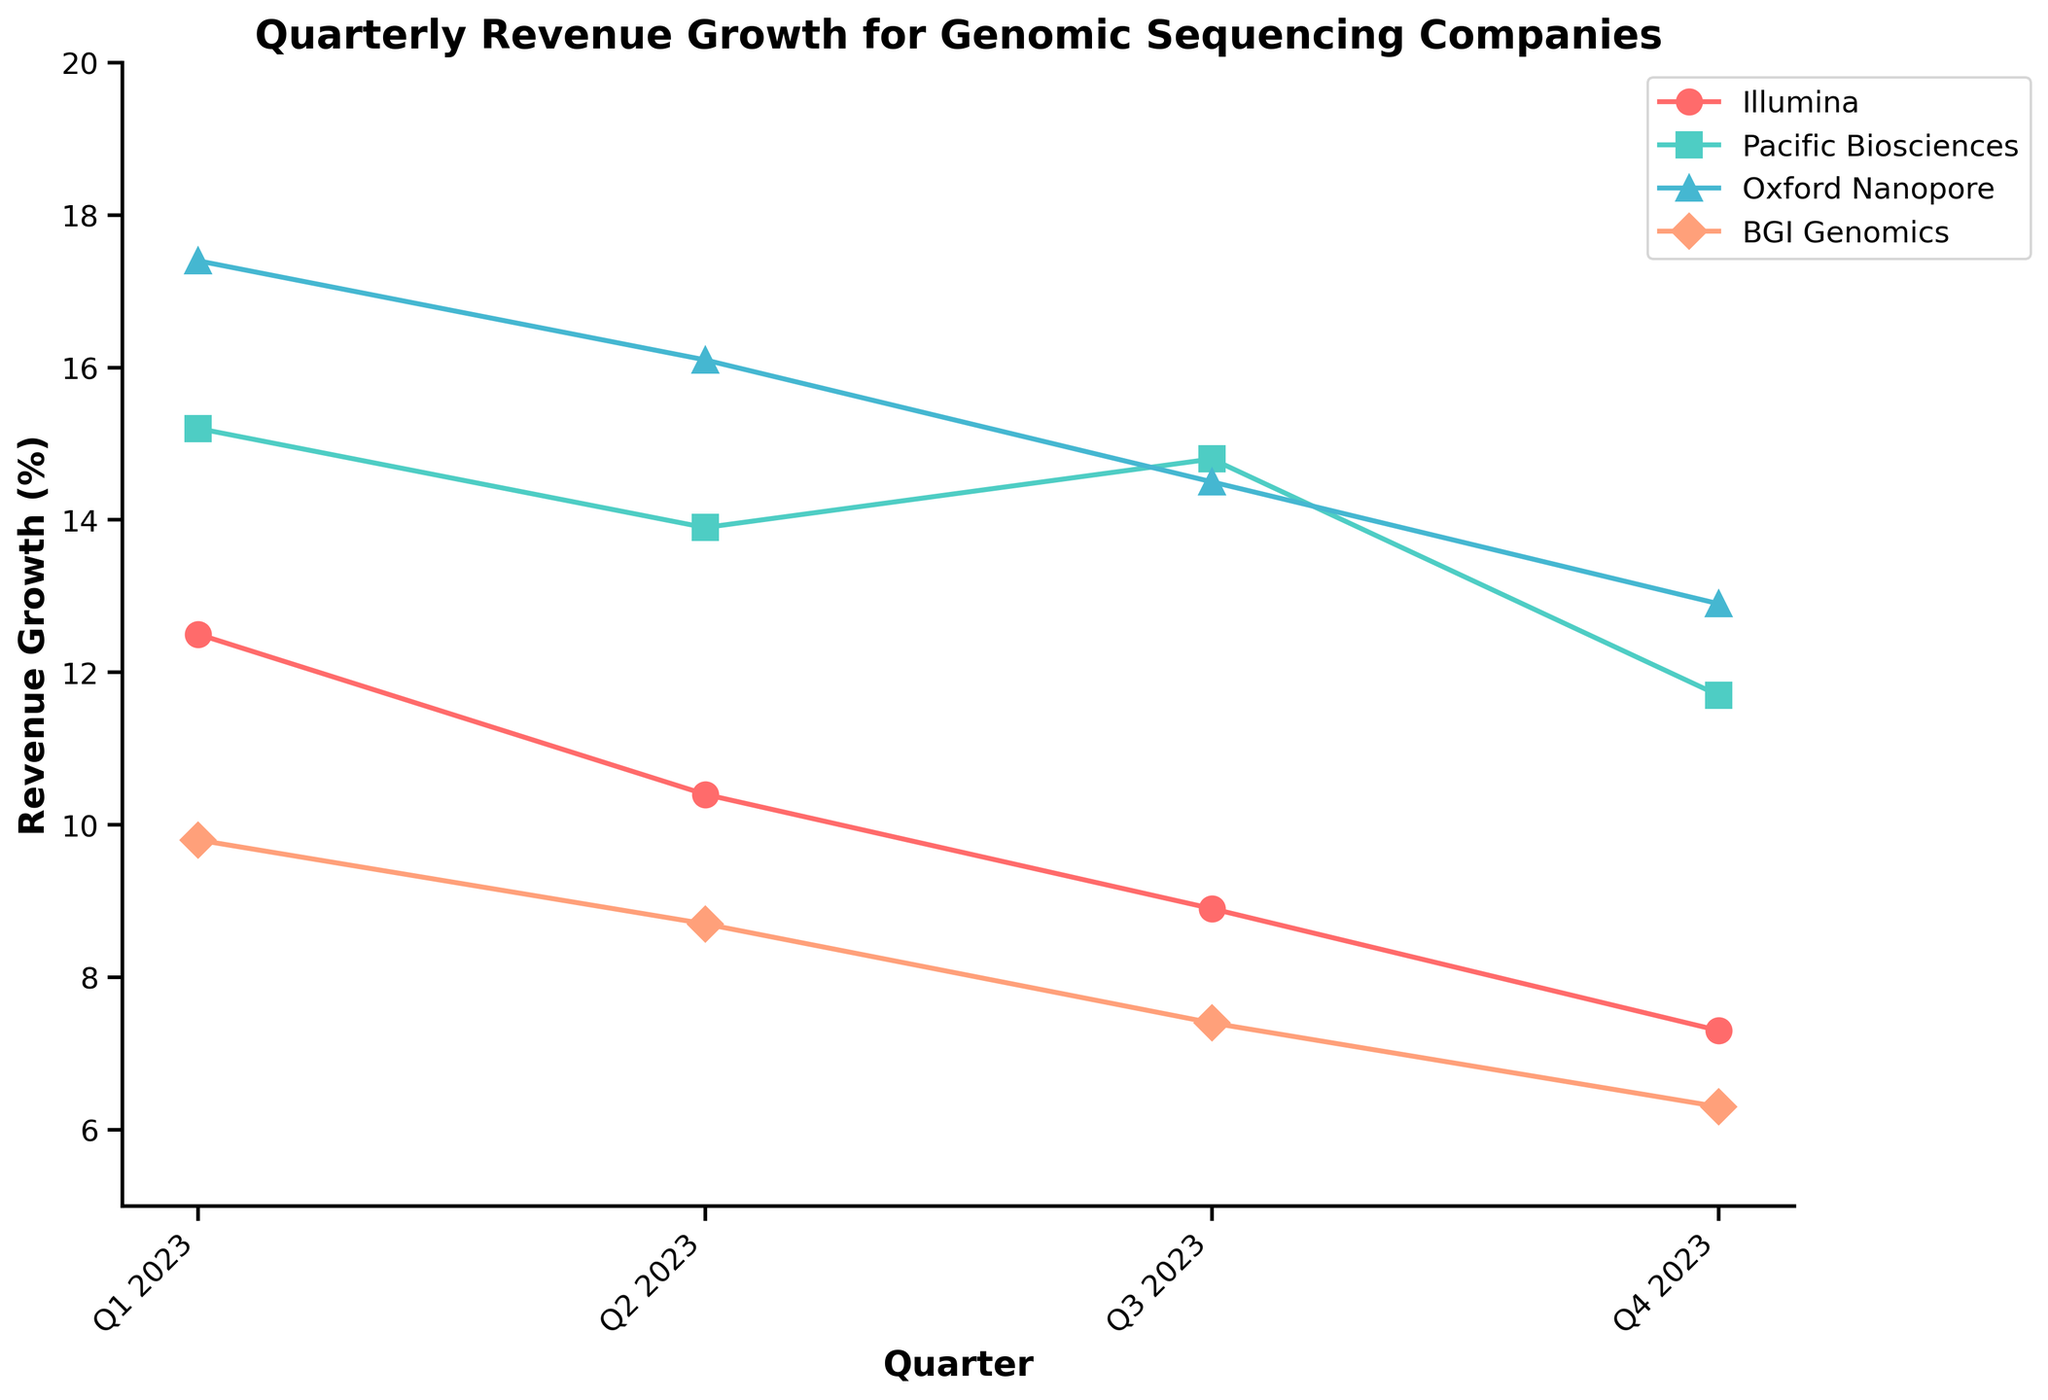what is the title of the plot? The question is asking for the main heading of the plotted figure. The title is usually displayed prominently at the top of the plot.
Answer: Quarterly Revenue Growth for Genomic Sequencing Companies which company shows the highest revenue growth in Q1 2023? Look at the plotted points for Q1 2023 across all companies and identify the company with the highest value.
Answer: Oxford Nanopore how do the revenue growth percentages of Pacific Biosciences and BGI Genomics for Q4 2023 compare? Locate the data points for Q4 2023 for both Pacific Biosciences and BGI Genomics and compare their values.
Answer: Pacific Biosciences has higher revenue growth than BGI Genomics what is the average revenue growth of Illumina across all quarters? Add the revenue growth percentages of Illumina for each quarter and divide by the number of quarters (4). (12.5 + 10.4 + 8.9 + 7.3) / 4
Answer: 9.775% which company had the greatest decline in revenue growth from Q1 to Q4 2023? Calculate the decline in revenue growth for each company from Q1 to Q4 2023 and identify the company with the largest drop.
Answer: BGI Genomics which quarter had the overall highest average revenue growth among all companies? Calculate the average revenue growth for each quarter by summing the growth percentages of all companies and dividing by the number of companies. Compare the averages across the quarters.
Answer: Q1 2023 did any company have a consistent decline in revenue growth over the quarters? Examine the trend for each company across all quarters to see if the revenue growth percentage decreases consecutively.
Answer: Illumina how many companies had a higher revenue growth in Q4 2023 compared to Q3 2023? Compare the revenue growth percentages between Q3 and Q4 2023 for each company and count the number of companies with higher values in Q4.
Answer: 0 which company had the smallest change in revenue growth between the last two quarters (Q3 and Q4 2023)? For each company, calculate the absolute difference in revenue growth between Q3 and Q4 2023 and find the company with the smallest change.
Answer: Oxford Nanopore 